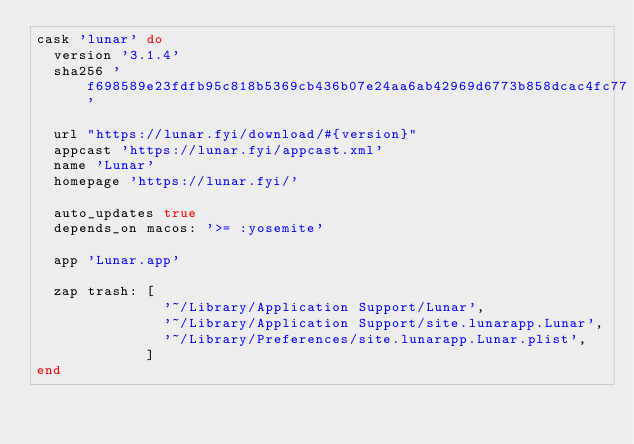<code> <loc_0><loc_0><loc_500><loc_500><_Ruby_>cask 'lunar' do
  version '3.1.4'
  sha256 'f698589e23fdfb95c818b5369cb436b07e24aa6ab42969d6773b858dcac4fc77'

  url "https://lunar.fyi/download/#{version}"
  appcast 'https://lunar.fyi/appcast.xml'
  name 'Lunar'
  homepage 'https://lunar.fyi/'

  auto_updates true
  depends_on macos: '>= :yosemite'

  app 'Lunar.app'

  zap trash: [
               '~/Library/Application Support/Lunar',
               '~/Library/Application Support/site.lunarapp.Lunar',
               '~/Library/Preferences/site.lunarapp.Lunar.plist',
             ]
end
</code> 